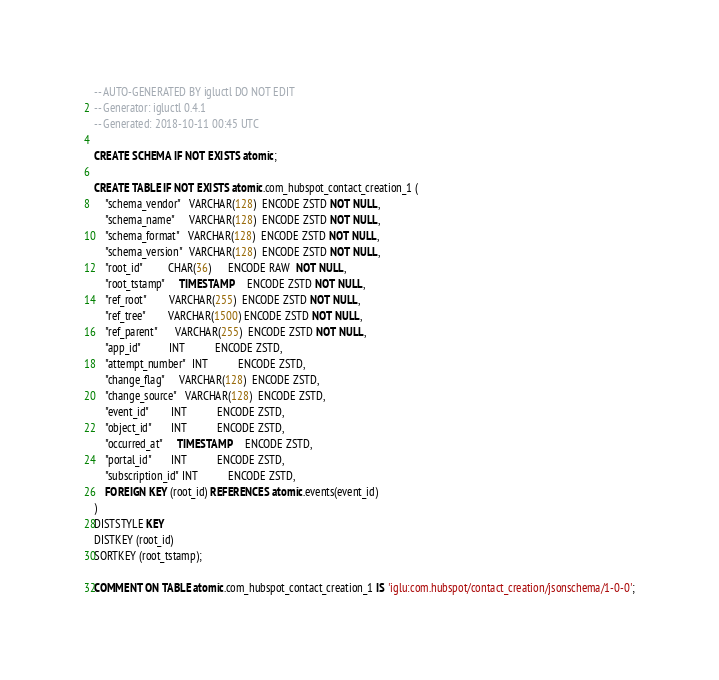<code> <loc_0><loc_0><loc_500><loc_500><_SQL_>-- AUTO-GENERATED BY igluctl DO NOT EDIT
-- Generator: igluctl 0.4.1
-- Generated: 2018-10-11 00:45 UTC

CREATE SCHEMA IF NOT EXISTS atomic;

CREATE TABLE IF NOT EXISTS atomic.com_hubspot_contact_creation_1 (
    "schema_vendor"   VARCHAR(128)  ENCODE ZSTD NOT NULL,
    "schema_name"     VARCHAR(128)  ENCODE ZSTD NOT NULL,
    "schema_format"   VARCHAR(128)  ENCODE ZSTD NOT NULL,
    "schema_version"  VARCHAR(128)  ENCODE ZSTD NOT NULL,
    "root_id"         CHAR(36)      ENCODE RAW  NOT NULL,
    "root_tstamp"     TIMESTAMP     ENCODE ZSTD NOT NULL,
    "ref_root"        VARCHAR(255)  ENCODE ZSTD NOT NULL,
    "ref_tree"        VARCHAR(1500) ENCODE ZSTD NOT NULL,
    "ref_parent"      VARCHAR(255)  ENCODE ZSTD NOT NULL,
    "app_id"          INT           ENCODE ZSTD,
    "attempt_number"  INT           ENCODE ZSTD,
    "change_flag"     VARCHAR(128)  ENCODE ZSTD,
    "change_source"   VARCHAR(128)  ENCODE ZSTD,
    "event_id"        INT           ENCODE ZSTD,
    "object_id"       INT           ENCODE ZSTD,
    "occurred_at"     TIMESTAMP     ENCODE ZSTD,
    "portal_id"       INT           ENCODE ZSTD,
    "subscription_id" INT           ENCODE ZSTD,
    FOREIGN KEY (root_id) REFERENCES atomic.events(event_id)
)
DISTSTYLE KEY
DISTKEY (root_id)
SORTKEY (root_tstamp);

COMMENT ON TABLE atomic.com_hubspot_contact_creation_1 IS 'iglu:com.hubspot/contact_creation/jsonschema/1-0-0';
</code> 